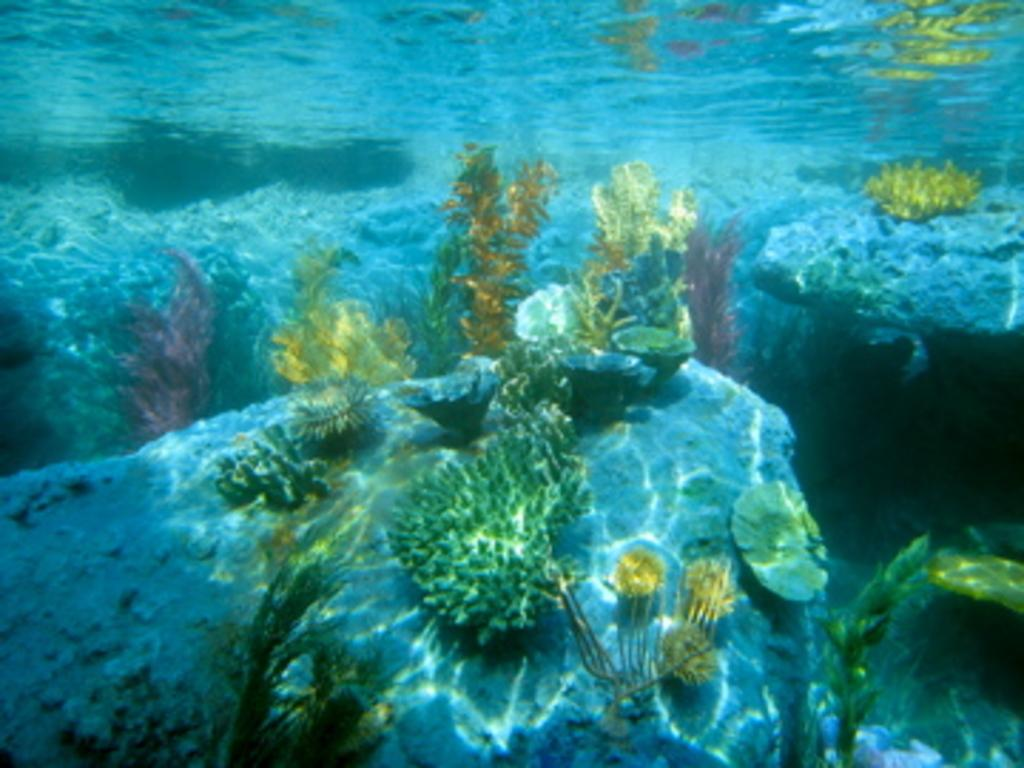What type of environment is depicted in the image? The image shows an area with water around it. What can be seen in the center of the image? There are aquatic plants in the center of the image. How many dogs are sitting on the sofa in the image? There is no sofa or dogs present in the image. 